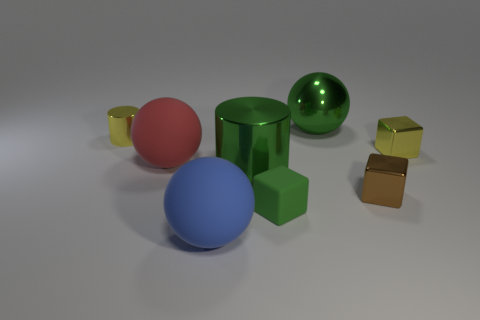Add 2 large red cubes. How many objects exist? 10 Subtract all yellow cylinders. How many cylinders are left? 1 Subtract all small brown metallic cubes. How many cubes are left? 2 Subtract all spheres. How many objects are left? 5 Subtract 1 balls. How many balls are left? 2 Add 3 red metal balls. How many red metal balls exist? 3 Subtract 0 red cylinders. How many objects are left? 8 Subtract all yellow blocks. Subtract all gray cylinders. How many blocks are left? 2 Subtract all brown cylinders. How many green spheres are left? 1 Subtract all brown shiny objects. Subtract all large blue things. How many objects are left? 6 